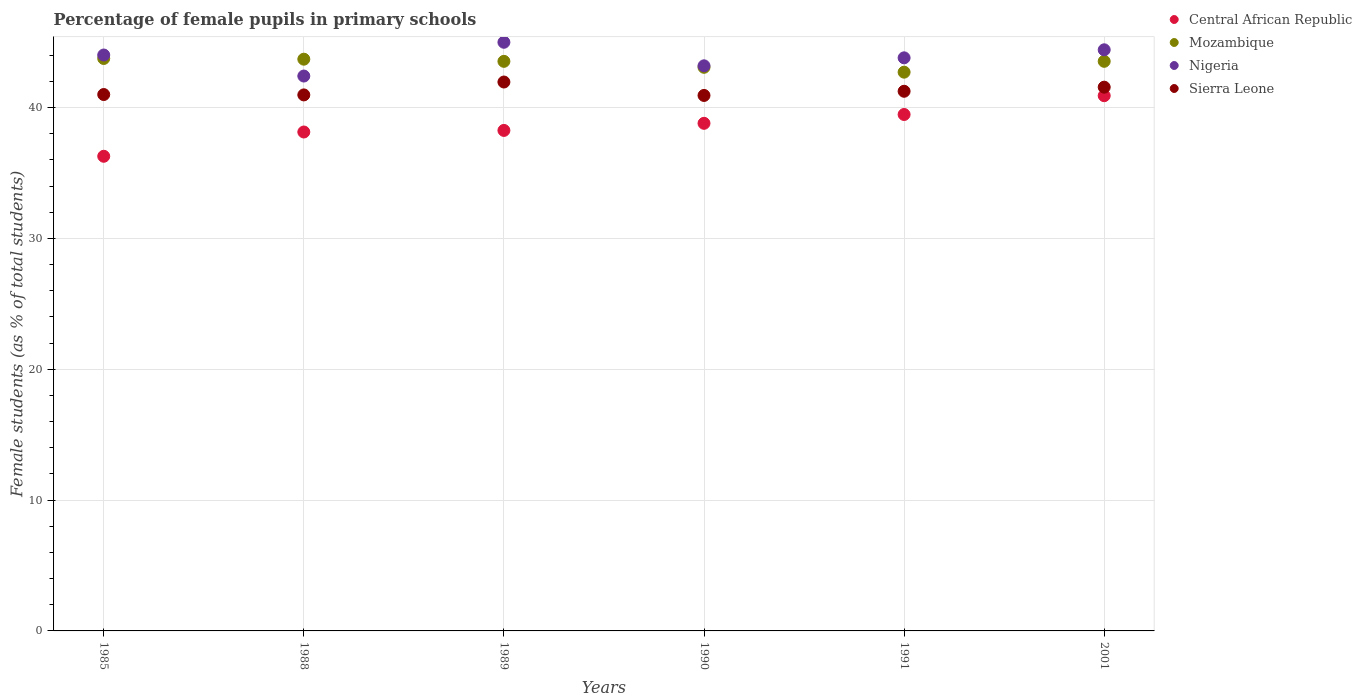What is the percentage of female pupils in primary schools in Mozambique in 1991?
Provide a succinct answer. 42.71. Across all years, what is the maximum percentage of female pupils in primary schools in Nigeria?
Offer a very short reply. 44.99. Across all years, what is the minimum percentage of female pupils in primary schools in Nigeria?
Your answer should be very brief. 42.41. What is the total percentage of female pupils in primary schools in Nigeria in the graph?
Keep it short and to the point. 262.85. What is the difference between the percentage of female pupils in primary schools in Mozambique in 1988 and that in 1991?
Keep it short and to the point. 0.99. What is the difference between the percentage of female pupils in primary schools in Central African Republic in 1985 and the percentage of female pupils in primary schools in Mozambique in 1991?
Your answer should be very brief. -6.43. What is the average percentage of female pupils in primary schools in Mozambique per year?
Offer a terse response. 43.39. In the year 1985, what is the difference between the percentage of female pupils in primary schools in Nigeria and percentage of female pupils in primary schools in Central African Republic?
Provide a short and direct response. 7.74. In how many years, is the percentage of female pupils in primary schools in Mozambique greater than 34 %?
Make the answer very short. 6. What is the ratio of the percentage of female pupils in primary schools in Sierra Leone in 1991 to that in 2001?
Provide a succinct answer. 0.99. Is the difference between the percentage of female pupils in primary schools in Nigeria in 1985 and 1989 greater than the difference between the percentage of female pupils in primary schools in Central African Republic in 1985 and 1989?
Offer a terse response. Yes. What is the difference between the highest and the second highest percentage of female pupils in primary schools in Nigeria?
Offer a very short reply. 0.58. What is the difference between the highest and the lowest percentage of female pupils in primary schools in Nigeria?
Keep it short and to the point. 2.58. In how many years, is the percentage of female pupils in primary schools in Sierra Leone greater than the average percentage of female pupils in primary schools in Sierra Leone taken over all years?
Your answer should be compact. 2. Is it the case that in every year, the sum of the percentage of female pupils in primary schools in Sierra Leone and percentage of female pupils in primary schools in Nigeria  is greater than the percentage of female pupils in primary schools in Mozambique?
Ensure brevity in your answer.  Yes. Does the percentage of female pupils in primary schools in Mozambique monotonically increase over the years?
Ensure brevity in your answer.  No. Is the percentage of female pupils in primary schools in Mozambique strictly greater than the percentage of female pupils in primary schools in Nigeria over the years?
Ensure brevity in your answer.  No. How many dotlines are there?
Offer a very short reply. 4. How many years are there in the graph?
Keep it short and to the point. 6. Are the values on the major ticks of Y-axis written in scientific E-notation?
Your answer should be compact. No. Where does the legend appear in the graph?
Your answer should be very brief. Top right. What is the title of the graph?
Offer a very short reply. Percentage of female pupils in primary schools. What is the label or title of the Y-axis?
Give a very brief answer. Female students (as % of total students). What is the Female students (as % of total students) in Central African Republic in 1985?
Provide a succinct answer. 36.28. What is the Female students (as % of total students) of Mozambique in 1985?
Offer a very short reply. 43.76. What is the Female students (as % of total students) of Nigeria in 1985?
Offer a very short reply. 44.02. What is the Female students (as % of total students) of Sierra Leone in 1985?
Your answer should be compact. 41. What is the Female students (as % of total students) in Central African Republic in 1988?
Give a very brief answer. 38.14. What is the Female students (as % of total students) in Mozambique in 1988?
Your answer should be compact. 43.7. What is the Female students (as % of total students) of Nigeria in 1988?
Offer a very short reply. 42.41. What is the Female students (as % of total students) of Sierra Leone in 1988?
Keep it short and to the point. 40.97. What is the Female students (as % of total students) of Central African Republic in 1989?
Offer a terse response. 38.26. What is the Female students (as % of total students) of Mozambique in 1989?
Provide a short and direct response. 43.54. What is the Female students (as % of total students) of Nigeria in 1989?
Give a very brief answer. 44.99. What is the Female students (as % of total students) in Sierra Leone in 1989?
Your answer should be compact. 41.96. What is the Female students (as % of total students) of Central African Republic in 1990?
Provide a short and direct response. 38.8. What is the Female students (as % of total students) in Mozambique in 1990?
Ensure brevity in your answer.  43.08. What is the Female students (as % of total students) in Nigeria in 1990?
Make the answer very short. 43.19. What is the Female students (as % of total students) in Sierra Leone in 1990?
Make the answer very short. 40.93. What is the Female students (as % of total students) of Central African Republic in 1991?
Your answer should be compact. 39.47. What is the Female students (as % of total students) in Mozambique in 1991?
Make the answer very short. 42.71. What is the Female students (as % of total students) of Nigeria in 1991?
Offer a terse response. 43.81. What is the Female students (as % of total students) of Sierra Leone in 1991?
Your answer should be compact. 41.25. What is the Female students (as % of total students) in Central African Republic in 2001?
Your answer should be compact. 40.91. What is the Female students (as % of total students) of Mozambique in 2001?
Your answer should be compact. 43.54. What is the Female students (as % of total students) of Nigeria in 2001?
Provide a succinct answer. 44.42. What is the Female students (as % of total students) in Sierra Leone in 2001?
Your answer should be very brief. 41.56. Across all years, what is the maximum Female students (as % of total students) of Central African Republic?
Make the answer very short. 40.91. Across all years, what is the maximum Female students (as % of total students) of Mozambique?
Make the answer very short. 43.76. Across all years, what is the maximum Female students (as % of total students) of Nigeria?
Offer a terse response. 44.99. Across all years, what is the maximum Female students (as % of total students) of Sierra Leone?
Offer a terse response. 41.96. Across all years, what is the minimum Female students (as % of total students) in Central African Republic?
Make the answer very short. 36.28. Across all years, what is the minimum Female students (as % of total students) of Mozambique?
Provide a short and direct response. 42.71. Across all years, what is the minimum Female students (as % of total students) in Nigeria?
Your answer should be compact. 42.41. Across all years, what is the minimum Female students (as % of total students) of Sierra Leone?
Provide a short and direct response. 40.93. What is the total Female students (as % of total students) of Central African Republic in the graph?
Keep it short and to the point. 231.86. What is the total Female students (as % of total students) of Mozambique in the graph?
Your answer should be very brief. 260.32. What is the total Female students (as % of total students) of Nigeria in the graph?
Provide a short and direct response. 262.85. What is the total Female students (as % of total students) of Sierra Leone in the graph?
Offer a terse response. 247.67. What is the difference between the Female students (as % of total students) in Central African Republic in 1985 and that in 1988?
Offer a very short reply. -1.86. What is the difference between the Female students (as % of total students) in Mozambique in 1985 and that in 1988?
Make the answer very short. 0.05. What is the difference between the Female students (as % of total students) of Nigeria in 1985 and that in 1988?
Provide a succinct answer. 1.61. What is the difference between the Female students (as % of total students) in Sierra Leone in 1985 and that in 1988?
Your answer should be very brief. 0.03. What is the difference between the Female students (as % of total students) in Central African Republic in 1985 and that in 1989?
Offer a terse response. -1.98. What is the difference between the Female students (as % of total students) of Mozambique in 1985 and that in 1989?
Provide a short and direct response. 0.22. What is the difference between the Female students (as % of total students) in Nigeria in 1985 and that in 1989?
Make the answer very short. -0.97. What is the difference between the Female students (as % of total students) in Sierra Leone in 1985 and that in 1989?
Ensure brevity in your answer.  -0.96. What is the difference between the Female students (as % of total students) of Central African Republic in 1985 and that in 1990?
Offer a terse response. -2.52. What is the difference between the Female students (as % of total students) in Mozambique in 1985 and that in 1990?
Ensure brevity in your answer.  0.68. What is the difference between the Female students (as % of total students) in Nigeria in 1985 and that in 1990?
Keep it short and to the point. 0.83. What is the difference between the Female students (as % of total students) of Sierra Leone in 1985 and that in 1990?
Keep it short and to the point. 0.07. What is the difference between the Female students (as % of total students) in Central African Republic in 1985 and that in 1991?
Ensure brevity in your answer.  -3.19. What is the difference between the Female students (as % of total students) in Mozambique in 1985 and that in 1991?
Offer a very short reply. 1.05. What is the difference between the Female students (as % of total students) in Nigeria in 1985 and that in 1991?
Provide a short and direct response. 0.22. What is the difference between the Female students (as % of total students) in Sierra Leone in 1985 and that in 1991?
Give a very brief answer. -0.25. What is the difference between the Female students (as % of total students) of Central African Republic in 1985 and that in 2001?
Keep it short and to the point. -4.63. What is the difference between the Female students (as % of total students) in Mozambique in 1985 and that in 2001?
Ensure brevity in your answer.  0.22. What is the difference between the Female students (as % of total students) in Nigeria in 1985 and that in 2001?
Give a very brief answer. -0.4. What is the difference between the Female students (as % of total students) of Sierra Leone in 1985 and that in 2001?
Ensure brevity in your answer.  -0.56. What is the difference between the Female students (as % of total students) of Central African Republic in 1988 and that in 1989?
Give a very brief answer. -0.12. What is the difference between the Female students (as % of total students) of Mozambique in 1988 and that in 1989?
Keep it short and to the point. 0.17. What is the difference between the Female students (as % of total students) in Nigeria in 1988 and that in 1989?
Your answer should be very brief. -2.58. What is the difference between the Female students (as % of total students) in Sierra Leone in 1988 and that in 1989?
Offer a terse response. -0.99. What is the difference between the Female students (as % of total students) of Central African Republic in 1988 and that in 1990?
Make the answer very short. -0.66. What is the difference between the Female students (as % of total students) of Mozambique in 1988 and that in 1990?
Provide a short and direct response. 0.62. What is the difference between the Female students (as % of total students) of Nigeria in 1988 and that in 1990?
Ensure brevity in your answer.  -0.78. What is the difference between the Female students (as % of total students) in Sierra Leone in 1988 and that in 1990?
Your answer should be compact. 0.04. What is the difference between the Female students (as % of total students) of Central African Republic in 1988 and that in 1991?
Provide a succinct answer. -1.34. What is the difference between the Female students (as % of total students) in Nigeria in 1988 and that in 1991?
Your answer should be very brief. -1.39. What is the difference between the Female students (as % of total students) in Sierra Leone in 1988 and that in 1991?
Give a very brief answer. -0.28. What is the difference between the Female students (as % of total students) in Central African Republic in 1988 and that in 2001?
Offer a terse response. -2.78. What is the difference between the Female students (as % of total students) of Mozambique in 1988 and that in 2001?
Your answer should be very brief. 0.16. What is the difference between the Female students (as % of total students) in Nigeria in 1988 and that in 2001?
Your answer should be compact. -2.01. What is the difference between the Female students (as % of total students) of Sierra Leone in 1988 and that in 2001?
Your answer should be very brief. -0.59. What is the difference between the Female students (as % of total students) in Central African Republic in 1989 and that in 1990?
Make the answer very short. -0.54. What is the difference between the Female students (as % of total students) of Mozambique in 1989 and that in 1990?
Your answer should be compact. 0.46. What is the difference between the Female students (as % of total students) of Nigeria in 1989 and that in 1990?
Provide a short and direct response. 1.8. What is the difference between the Female students (as % of total students) in Sierra Leone in 1989 and that in 1990?
Provide a short and direct response. 1.03. What is the difference between the Female students (as % of total students) in Central African Republic in 1989 and that in 1991?
Make the answer very short. -1.22. What is the difference between the Female students (as % of total students) of Mozambique in 1989 and that in 1991?
Make the answer very short. 0.83. What is the difference between the Female students (as % of total students) of Nigeria in 1989 and that in 1991?
Offer a very short reply. 1.19. What is the difference between the Female students (as % of total students) in Sierra Leone in 1989 and that in 1991?
Your response must be concise. 0.71. What is the difference between the Female students (as % of total students) in Central African Republic in 1989 and that in 2001?
Ensure brevity in your answer.  -2.65. What is the difference between the Female students (as % of total students) in Mozambique in 1989 and that in 2001?
Provide a short and direct response. -0. What is the difference between the Female students (as % of total students) of Nigeria in 1989 and that in 2001?
Provide a succinct answer. 0.58. What is the difference between the Female students (as % of total students) of Sierra Leone in 1989 and that in 2001?
Your response must be concise. 0.39. What is the difference between the Female students (as % of total students) in Central African Republic in 1990 and that in 1991?
Your response must be concise. -0.68. What is the difference between the Female students (as % of total students) in Mozambique in 1990 and that in 1991?
Provide a short and direct response. 0.37. What is the difference between the Female students (as % of total students) of Nigeria in 1990 and that in 1991?
Make the answer very short. -0.61. What is the difference between the Female students (as % of total students) of Sierra Leone in 1990 and that in 1991?
Give a very brief answer. -0.32. What is the difference between the Female students (as % of total students) in Central African Republic in 1990 and that in 2001?
Your response must be concise. -2.11. What is the difference between the Female students (as % of total students) of Mozambique in 1990 and that in 2001?
Your answer should be compact. -0.46. What is the difference between the Female students (as % of total students) in Nigeria in 1990 and that in 2001?
Keep it short and to the point. -1.22. What is the difference between the Female students (as % of total students) of Sierra Leone in 1990 and that in 2001?
Your answer should be very brief. -0.63. What is the difference between the Female students (as % of total students) of Central African Republic in 1991 and that in 2001?
Provide a succinct answer. -1.44. What is the difference between the Female students (as % of total students) in Mozambique in 1991 and that in 2001?
Make the answer very short. -0.83. What is the difference between the Female students (as % of total students) of Nigeria in 1991 and that in 2001?
Provide a succinct answer. -0.61. What is the difference between the Female students (as % of total students) of Sierra Leone in 1991 and that in 2001?
Your answer should be very brief. -0.31. What is the difference between the Female students (as % of total students) in Central African Republic in 1985 and the Female students (as % of total students) in Mozambique in 1988?
Your answer should be very brief. -7.42. What is the difference between the Female students (as % of total students) in Central African Republic in 1985 and the Female students (as % of total students) in Nigeria in 1988?
Your response must be concise. -6.13. What is the difference between the Female students (as % of total students) of Central African Republic in 1985 and the Female students (as % of total students) of Sierra Leone in 1988?
Give a very brief answer. -4.69. What is the difference between the Female students (as % of total students) in Mozambique in 1985 and the Female students (as % of total students) in Nigeria in 1988?
Make the answer very short. 1.34. What is the difference between the Female students (as % of total students) of Mozambique in 1985 and the Female students (as % of total students) of Sierra Leone in 1988?
Ensure brevity in your answer.  2.78. What is the difference between the Female students (as % of total students) in Nigeria in 1985 and the Female students (as % of total students) in Sierra Leone in 1988?
Your answer should be very brief. 3.05. What is the difference between the Female students (as % of total students) of Central African Republic in 1985 and the Female students (as % of total students) of Mozambique in 1989?
Offer a terse response. -7.26. What is the difference between the Female students (as % of total students) in Central African Republic in 1985 and the Female students (as % of total students) in Nigeria in 1989?
Your answer should be compact. -8.71. What is the difference between the Female students (as % of total students) in Central African Republic in 1985 and the Female students (as % of total students) in Sierra Leone in 1989?
Make the answer very short. -5.68. What is the difference between the Female students (as % of total students) in Mozambique in 1985 and the Female students (as % of total students) in Nigeria in 1989?
Provide a succinct answer. -1.24. What is the difference between the Female students (as % of total students) in Mozambique in 1985 and the Female students (as % of total students) in Sierra Leone in 1989?
Provide a short and direct response. 1.8. What is the difference between the Female students (as % of total students) of Nigeria in 1985 and the Female students (as % of total students) of Sierra Leone in 1989?
Provide a succinct answer. 2.06. What is the difference between the Female students (as % of total students) in Central African Republic in 1985 and the Female students (as % of total students) in Mozambique in 1990?
Provide a succinct answer. -6.8. What is the difference between the Female students (as % of total students) in Central African Republic in 1985 and the Female students (as % of total students) in Nigeria in 1990?
Your response must be concise. -6.91. What is the difference between the Female students (as % of total students) in Central African Republic in 1985 and the Female students (as % of total students) in Sierra Leone in 1990?
Keep it short and to the point. -4.65. What is the difference between the Female students (as % of total students) in Mozambique in 1985 and the Female students (as % of total students) in Nigeria in 1990?
Offer a terse response. 0.56. What is the difference between the Female students (as % of total students) in Mozambique in 1985 and the Female students (as % of total students) in Sierra Leone in 1990?
Your response must be concise. 2.83. What is the difference between the Female students (as % of total students) in Nigeria in 1985 and the Female students (as % of total students) in Sierra Leone in 1990?
Make the answer very short. 3.09. What is the difference between the Female students (as % of total students) in Central African Republic in 1985 and the Female students (as % of total students) in Mozambique in 1991?
Make the answer very short. -6.43. What is the difference between the Female students (as % of total students) of Central African Republic in 1985 and the Female students (as % of total students) of Nigeria in 1991?
Give a very brief answer. -7.52. What is the difference between the Female students (as % of total students) of Central African Republic in 1985 and the Female students (as % of total students) of Sierra Leone in 1991?
Ensure brevity in your answer.  -4.97. What is the difference between the Female students (as % of total students) in Mozambique in 1985 and the Female students (as % of total students) in Nigeria in 1991?
Provide a short and direct response. -0.05. What is the difference between the Female students (as % of total students) in Mozambique in 1985 and the Female students (as % of total students) in Sierra Leone in 1991?
Provide a succinct answer. 2.51. What is the difference between the Female students (as % of total students) of Nigeria in 1985 and the Female students (as % of total students) of Sierra Leone in 1991?
Keep it short and to the point. 2.77. What is the difference between the Female students (as % of total students) in Central African Republic in 1985 and the Female students (as % of total students) in Mozambique in 2001?
Offer a terse response. -7.26. What is the difference between the Female students (as % of total students) in Central African Republic in 1985 and the Female students (as % of total students) in Nigeria in 2001?
Ensure brevity in your answer.  -8.14. What is the difference between the Female students (as % of total students) of Central African Republic in 1985 and the Female students (as % of total students) of Sierra Leone in 2001?
Your response must be concise. -5.28. What is the difference between the Female students (as % of total students) in Mozambique in 1985 and the Female students (as % of total students) in Nigeria in 2001?
Ensure brevity in your answer.  -0.66. What is the difference between the Female students (as % of total students) in Mozambique in 1985 and the Female students (as % of total students) in Sierra Leone in 2001?
Provide a short and direct response. 2.19. What is the difference between the Female students (as % of total students) in Nigeria in 1985 and the Female students (as % of total students) in Sierra Leone in 2001?
Keep it short and to the point. 2.46. What is the difference between the Female students (as % of total students) of Central African Republic in 1988 and the Female students (as % of total students) of Mozambique in 1989?
Make the answer very short. -5.4. What is the difference between the Female students (as % of total students) of Central African Republic in 1988 and the Female students (as % of total students) of Nigeria in 1989?
Offer a very short reply. -6.86. What is the difference between the Female students (as % of total students) in Central African Republic in 1988 and the Female students (as % of total students) in Sierra Leone in 1989?
Offer a very short reply. -3.82. What is the difference between the Female students (as % of total students) of Mozambique in 1988 and the Female students (as % of total students) of Nigeria in 1989?
Ensure brevity in your answer.  -1.29. What is the difference between the Female students (as % of total students) in Mozambique in 1988 and the Female students (as % of total students) in Sierra Leone in 1989?
Your response must be concise. 1.75. What is the difference between the Female students (as % of total students) of Nigeria in 1988 and the Female students (as % of total students) of Sierra Leone in 1989?
Ensure brevity in your answer.  0.46. What is the difference between the Female students (as % of total students) of Central African Republic in 1988 and the Female students (as % of total students) of Mozambique in 1990?
Keep it short and to the point. -4.95. What is the difference between the Female students (as % of total students) in Central African Republic in 1988 and the Female students (as % of total students) in Nigeria in 1990?
Your answer should be very brief. -5.06. What is the difference between the Female students (as % of total students) in Central African Republic in 1988 and the Female students (as % of total students) in Sierra Leone in 1990?
Offer a very short reply. -2.79. What is the difference between the Female students (as % of total students) in Mozambique in 1988 and the Female students (as % of total students) in Nigeria in 1990?
Your response must be concise. 0.51. What is the difference between the Female students (as % of total students) in Mozambique in 1988 and the Female students (as % of total students) in Sierra Leone in 1990?
Offer a terse response. 2.77. What is the difference between the Female students (as % of total students) of Nigeria in 1988 and the Female students (as % of total students) of Sierra Leone in 1990?
Give a very brief answer. 1.48. What is the difference between the Female students (as % of total students) in Central African Republic in 1988 and the Female students (as % of total students) in Mozambique in 1991?
Provide a succinct answer. -4.57. What is the difference between the Female students (as % of total students) of Central African Republic in 1988 and the Female students (as % of total students) of Nigeria in 1991?
Keep it short and to the point. -5.67. What is the difference between the Female students (as % of total students) of Central African Republic in 1988 and the Female students (as % of total students) of Sierra Leone in 1991?
Offer a terse response. -3.11. What is the difference between the Female students (as % of total students) of Mozambique in 1988 and the Female students (as % of total students) of Nigeria in 1991?
Keep it short and to the point. -0.1. What is the difference between the Female students (as % of total students) in Mozambique in 1988 and the Female students (as % of total students) in Sierra Leone in 1991?
Provide a succinct answer. 2.45. What is the difference between the Female students (as % of total students) of Nigeria in 1988 and the Female students (as % of total students) of Sierra Leone in 1991?
Ensure brevity in your answer.  1.16. What is the difference between the Female students (as % of total students) of Central African Republic in 1988 and the Female students (as % of total students) of Mozambique in 2001?
Offer a terse response. -5.4. What is the difference between the Female students (as % of total students) in Central African Republic in 1988 and the Female students (as % of total students) in Nigeria in 2001?
Your answer should be compact. -6.28. What is the difference between the Female students (as % of total students) in Central African Republic in 1988 and the Female students (as % of total students) in Sierra Leone in 2001?
Offer a terse response. -3.43. What is the difference between the Female students (as % of total students) of Mozambique in 1988 and the Female students (as % of total students) of Nigeria in 2001?
Make the answer very short. -0.72. What is the difference between the Female students (as % of total students) in Mozambique in 1988 and the Female students (as % of total students) in Sierra Leone in 2001?
Keep it short and to the point. 2.14. What is the difference between the Female students (as % of total students) of Nigeria in 1988 and the Female students (as % of total students) of Sierra Leone in 2001?
Keep it short and to the point. 0.85. What is the difference between the Female students (as % of total students) of Central African Republic in 1989 and the Female students (as % of total students) of Mozambique in 1990?
Keep it short and to the point. -4.82. What is the difference between the Female students (as % of total students) in Central African Republic in 1989 and the Female students (as % of total students) in Nigeria in 1990?
Your answer should be very brief. -4.94. What is the difference between the Female students (as % of total students) in Central African Republic in 1989 and the Female students (as % of total students) in Sierra Leone in 1990?
Your answer should be compact. -2.67. What is the difference between the Female students (as % of total students) of Mozambique in 1989 and the Female students (as % of total students) of Nigeria in 1990?
Your answer should be compact. 0.34. What is the difference between the Female students (as % of total students) in Mozambique in 1989 and the Female students (as % of total students) in Sierra Leone in 1990?
Keep it short and to the point. 2.61. What is the difference between the Female students (as % of total students) in Nigeria in 1989 and the Female students (as % of total students) in Sierra Leone in 1990?
Make the answer very short. 4.06. What is the difference between the Female students (as % of total students) in Central African Republic in 1989 and the Female students (as % of total students) in Mozambique in 1991?
Ensure brevity in your answer.  -4.45. What is the difference between the Female students (as % of total students) in Central African Republic in 1989 and the Female students (as % of total students) in Nigeria in 1991?
Your answer should be very brief. -5.55. What is the difference between the Female students (as % of total students) of Central African Republic in 1989 and the Female students (as % of total students) of Sierra Leone in 1991?
Offer a terse response. -2.99. What is the difference between the Female students (as % of total students) in Mozambique in 1989 and the Female students (as % of total students) in Nigeria in 1991?
Provide a short and direct response. -0.27. What is the difference between the Female students (as % of total students) in Mozambique in 1989 and the Female students (as % of total students) in Sierra Leone in 1991?
Offer a terse response. 2.29. What is the difference between the Female students (as % of total students) of Nigeria in 1989 and the Female students (as % of total students) of Sierra Leone in 1991?
Your answer should be compact. 3.74. What is the difference between the Female students (as % of total students) of Central African Republic in 1989 and the Female students (as % of total students) of Mozambique in 2001?
Keep it short and to the point. -5.28. What is the difference between the Female students (as % of total students) in Central African Republic in 1989 and the Female students (as % of total students) in Nigeria in 2001?
Your answer should be very brief. -6.16. What is the difference between the Female students (as % of total students) in Central African Republic in 1989 and the Female students (as % of total students) in Sierra Leone in 2001?
Offer a very short reply. -3.31. What is the difference between the Female students (as % of total students) in Mozambique in 1989 and the Female students (as % of total students) in Nigeria in 2001?
Make the answer very short. -0.88. What is the difference between the Female students (as % of total students) in Mozambique in 1989 and the Female students (as % of total students) in Sierra Leone in 2001?
Your answer should be compact. 1.97. What is the difference between the Female students (as % of total students) of Nigeria in 1989 and the Female students (as % of total students) of Sierra Leone in 2001?
Ensure brevity in your answer.  3.43. What is the difference between the Female students (as % of total students) of Central African Republic in 1990 and the Female students (as % of total students) of Mozambique in 1991?
Your answer should be very brief. -3.91. What is the difference between the Female students (as % of total students) in Central African Republic in 1990 and the Female students (as % of total students) in Nigeria in 1991?
Ensure brevity in your answer.  -5.01. What is the difference between the Female students (as % of total students) in Central African Republic in 1990 and the Female students (as % of total students) in Sierra Leone in 1991?
Your answer should be compact. -2.45. What is the difference between the Female students (as % of total students) in Mozambique in 1990 and the Female students (as % of total students) in Nigeria in 1991?
Keep it short and to the point. -0.72. What is the difference between the Female students (as % of total students) in Mozambique in 1990 and the Female students (as % of total students) in Sierra Leone in 1991?
Keep it short and to the point. 1.83. What is the difference between the Female students (as % of total students) of Nigeria in 1990 and the Female students (as % of total students) of Sierra Leone in 1991?
Ensure brevity in your answer.  1.95. What is the difference between the Female students (as % of total students) of Central African Republic in 1990 and the Female students (as % of total students) of Mozambique in 2001?
Make the answer very short. -4.74. What is the difference between the Female students (as % of total students) in Central African Republic in 1990 and the Female students (as % of total students) in Nigeria in 2001?
Offer a very short reply. -5.62. What is the difference between the Female students (as % of total students) of Central African Republic in 1990 and the Female students (as % of total students) of Sierra Leone in 2001?
Provide a short and direct response. -2.76. What is the difference between the Female students (as % of total students) in Mozambique in 1990 and the Female students (as % of total students) in Nigeria in 2001?
Keep it short and to the point. -1.34. What is the difference between the Female students (as % of total students) of Mozambique in 1990 and the Female students (as % of total students) of Sierra Leone in 2001?
Provide a succinct answer. 1.52. What is the difference between the Female students (as % of total students) of Nigeria in 1990 and the Female students (as % of total students) of Sierra Leone in 2001?
Your response must be concise. 1.63. What is the difference between the Female students (as % of total students) of Central African Republic in 1991 and the Female students (as % of total students) of Mozambique in 2001?
Provide a succinct answer. -4.06. What is the difference between the Female students (as % of total students) of Central African Republic in 1991 and the Female students (as % of total students) of Nigeria in 2001?
Keep it short and to the point. -4.94. What is the difference between the Female students (as % of total students) of Central African Republic in 1991 and the Female students (as % of total students) of Sierra Leone in 2001?
Your answer should be compact. -2.09. What is the difference between the Female students (as % of total students) of Mozambique in 1991 and the Female students (as % of total students) of Nigeria in 2001?
Provide a succinct answer. -1.71. What is the difference between the Female students (as % of total students) in Mozambique in 1991 and the Female students (as % of total students) in Sierra Leone in 2001?
Your answer should be compact. 1.15. What is the difference between the Female students (as % of total students) of Nigeria in 1991 and the Female students (as % of total students) of Sierra Leone in 2001?
Your answer should be very brief. 2.24. What is the average Female students (as % of total students) in Central African Republic per year?
Your answer should be very brief. 38.64. What is the average Female students (as % of total students) in Mozambique per year?
Offer a terse response. 43.39. What is the average Female students (as % of total students) in Nigeria per year?
Give a very brief answer. 43.81. What is the average Female students (as % of total students) of Sierra Leone per year?
Your answer should be compact. 41.28. In the year 1985, what is the difference between the Female students (as % of total students) of Central African Republic and Female students (as % of total students) of Mozambique?
Keep it short and to the point. -7.48. In the year 1985, what is the difference between the Female students (as % of total students) in Central African Republic and Female students (as % of total students) in Nigeria?
Your response must be concise. -7.74. In the year 1985, what is the difference between the Female students (as % of total students) in Central African Republic and Female students (as % of total students) in Sierra Leone?
Your response must be concise. -4.72. In the year 1985, what is the difference between the Female students (as % of total students) of Mozambique and Female students (as % of total students) of Nigeria?
Provide a short and direct response. -0.26. In the year 1985, what is the difference between the Female students (as % of total students) of Mozambique and Female students (as % of total students) of Sierra Leone?
Make the answer very short. 2.76. In the year 1985, what is the difference between the Female students (as % of total students) in Nigeria and Female students (as % of total students) in Sierra Leone?
Offer a terse response. 3.02. In the year 1988, what is the difference between the Female students (as % of total students) in Central African Republic and Female students (as % of total students) in Mozambique?
Give a very brief answer. -5.57. In the year 1988, what is the difference between the Female students (as % of total students) of Central African Republic and Female students (as % of total students) of Nigeria?
Your answer should be compact. -4.28. In the year 1988, what is the difference between the Female students (as % of total students) of Central African Republic and Female students (as % of total students) of Sierra Leone?
Give a very brief answer. -2.84. In the year 1988, what is the difference between the Female students (as % of total students) of Mozambique and Female students (as % of total students) of Nigeria?
Your response must be concise. 1.29. In the year 1988, what is the difference between the Female students (as % of total students) of Mozambique and Female students (as % of total students) of Sierra Leone?
Provide a short and direct response. 2.73. In the year 1988, what is the difference between the Female students (as % of total students) of Nigeria and Female students (as % of total students) of Sierra Leone?
Your response must be concise. 1.44. In the year 1989, what is the difference between the Female students (as % of total students) of Central African Republic and Female students (as % of total students) of Mozambique?
Ensure brevity in your answer.  -5.28. In the year 1989, what is the difference between the Female students (as % of total students) in Central African Republic and Female students (as % of total students) in Nigeria?
Give a very brief answer. -6.74. In the year 1989, what is the difference between the Female students (as % of total students) of Central African Republic and Female students (as % of total students) of Sierra Leone?
Keep it short and to the point. -3.7. In the year 1989, what is the difference between the Female students (as % of total students) of Mozambique and Female students (as % of total students) of Nigeria?
Ensure brevity in your answer.  -1.46. In the year 1989, what is the difference between the Female students (as % of total students) of Mozambique and Female students (as % of total students) of Sierra Leone?
Ensure brevity in your answer.  1.58. In the year 1989, what is the difference between the Female students (as % of total students) of Nigeria and Female students (as % of total students) of Sierra Leone?
Make the answer very short. 3.04. In the year 1990, what is the difference between the Female students (as % of total students) in Central African Republic and Female students (as % of total students) in Mozambique?
Your answer should be very brief. -4.28. In the year 1990, what is the difference between the Female students (as % of total students) in Central African Republic and Female students (as % of total students) in Nigeria?
Ensure brevity in your answer.  -4.4. In the year 1990, what is the difference between the Female students (as % of total students) of Central African Republic and Female students (as % of total students) of Sierra Leone?
Your response must be concise. -2.13. In the year 1990, what is the difference between the Female students (as % of total students) of Mozambique and Female students (as % of total students) of Nigeria?
Your answer should be very brief. -0.11. In the year 1990, what is the difference between the Female students (as % of total students) in Mozambique and Female students (as % of total students) in Sierra Leone?
Offer a terse response. 2.15. In the year 1990, what is the difference between the Female students (as % of total students) in Nigeria and Female students (as % of total students) in Sierra Leone?
Provide a succinct answer. 2.26. In the year 1991, what is the difference between the Female students (as % of total students) in Central African Republic and Female students (as % of total students) in Mozambique?
Your response must be concise. -3.23. In the year 1991, what is the difference between the Female students (as % of total students) of Central African Republic and Female students (as % of total students) of Nigeria?
Your response must be concise. -4.33. In the year 1991, what is the difference between the Female students (as % of total students) of Central African Republic and Female students (as % of total students) of Sierra Leone?
Keep it short and to the point. -1.77. In the year 1991, what is the difference between the Female students (as % of total students) in Mozambique and Female students (as % of total students) in Nigeria?
Offer a very short reply. -1.1. In the year 1991, what is the difference between the Female students (as % of total students) in Mozambique and Female students (as % of total students) in Sierra Leone?
Offer a terse response. 1.46. In the year 1991, what is the difference between the Female students (as % of total students) of Nigeria and Female students (as % of total students) of Sierra Leone?
Provide a succinct answer. 2.56. In the year 2001, what is the difference between the Female students (as % of total students) in Central African Republic and Female students (as % of total students) in Mozambique?
Make the answer very short. -2.63. In the year 2001, what is the difference between the Female students (as % of total students) of Central African Republic and Female students (as % of total students) of Nigeria?
Provide a short and direct response. -3.51. In the year 2001, what is the difference between the Female students (as % of total students) in Central African Republic and Female students (as % of total students) in Sierra Leone?
Your answer should be compact. -0.65. In the year 2001, what is the difference between the Female students (as % of total students) in Mozambique and Female students (as % of total students) in Nigeria?
Your answer should be compact. -0.88. In the year 2001, what is the difference between the Female students (as % of total students) in Mozambique and Female students (as % of total students) in Sierra Leone?
Keep it short and to the point. 1.98. In the year 2001, what is the difference between the Female students (as % of total students) in Nigeria and Female students (as % of total students) in Sierra Leone?
Offer a terse response. 2.86. What is the ratio of the Female students (as % of total students) of Central African Republic in 1985 to that in 1988?
Provide a succinct answer. 0.95. What is the ratio of the Female students (as % of total students) in Nigeria in 1985 to that in 1988?
Your answer should be very brief. 1.04. What is the ratio of the Female students (as % of total students) in Sierra Leone in 1985 to that in 1988?
Give a very brief answer. 1. What is the ratio of the Female students (as % of total students) of Central African Republic in 1985 to that in 1989?
Offer a very short reply. 0.95. What is the ratio of the Female students (as % of total students) in Mozambique in 1985 to that in 1989?
Your response must be concise. 1. What is the ratio of the Female students (as % of total students) in Nigeria in 1985 to that in 1989?
Offer a very short reply. 0.98. What is the ratio of the Female students (as % of total students) of Sierra Leone in 1985 to that in 1989?
Offer a very short reply. 0.98. What is the ratio of the Female students (as % of total students) of Central African Republic in 1985 to that in 1990?
Ensure brevity in your answer.  0.94. What is the ratio of the Female students (as % of total students) in Mozambique in 1985 to that in 1990?
Your answer should be very brief. 1.02. What is the ratio of the Female students (as % of total students) in Nigeria in 1985 to that in 1990?
Offer a very short reply. 1.02. What is the ratio of the Female students (as % of total students) in Central African Republic in 1985 to that in 1991?
Provide a short and direct response. 0.92. What is the ratio of the Female students (as % of total students) in Mozambique in 1985 to that in 1991?
Your response must be concise. 1.02. What is the ratio of the Female students (as % of total students) in Nigeria in 1985 to that in 1991?
Your answer should be very brief. 1. What is the ratio of the Female students (as % of total students) in Central African Republic in 1985 to that in 2001?
Ensure brevity in your answer.  0.89. What is the ratio of the Female students (as % of total students) in Mozambique in 1985 to that in 2001?
Ensure brevity in your answer.  1. What is the ratio of the Female students (as % of total students) of Sierra Leone in 1985 to that in 2001?
Your answer should be compact. 0.99. What is the ratio of the Female students (as % of total students) in Central African Republic in 1988 to that in 1989?
Ensure brevity in your answer.  1. What is the ratio of the Female students (as % of total students) in Mozambique in 1988 to that in 1989?
Keep it short and to the point. 1. What is the ratio of the Female students (as % of total students) of Nigeria in 1988 to that in 1989?
Give a very brief answer. 0.94. What is the ratio of the Female students (as % of total students) of Sierra Leone in 1988 to that in 1989?
Give a very brief answer. 0.98. What is the ratio of the Female students (as % of total students) of Central African Republic in 1988 to that in 1990?
Make the answer very short. 0.98. What is the ratio of the Female students (as % of total students) in Mozambique in 1988 to that in 1990?
Ensure brevity in your answer.  1.01. What is the ratio of the Female students (as % of total students) of Nigeria in 1988 to that in 1990?
Provide a succinct answer. 0.98. What is the ratio of the Female students (as % of total students) in Central African Republic in 1988 to that in 1991?
Provide a succinct answer. 0.97. What is the ratio of the Female students (as % of total students) of Mozambique in 1988 to that in 1991?
Provide a short and direct response. 1.02. What is the ratio of the Female students (as % of total students) in Nigeria in 1988 to that in 1991?
Provide a succinct answer. 0.97. What is the ratio of the Female students (as % of total students) of Sierra Leone in 1988 to that in 1991?
Ensure brevity in your answer.  0.99. What is the ratio of the Female students (as % of total students) of Central African Republic in 1988 to that in 2001?
Your response must be concise. 0.93. What is the ratio of the Female students (as % of total students) in Nigeria in 1988 to that in 2001?
Offer a terse response. 0.95. What is the ratio of the Female students (as % of total students) of Sierra Leone in 1988 to that in 2001?
Your response must be concise. 0.99. What is the ratio of the Female students (as % of total students) in Central African Republic in 1989 to that in 1990?
Ensure brevity in your answer.  0.99. What is the ratio of the Female students (as % of total students) of Mozambique in 1989 to that in 1990?
Give a very brief answer. 1.01. What is the ratio of the Female students (as % of total students) of Nigeria in 1989 to that in 1990?
Your answer should be compact. 1.04. What is the ratio of the Female students (as % of total students) of Sierra Leone in 1989 to that in 1990?
Offer a terse response. 1.03. What is the ratio of the Female students (as % of total students) of Central African Republic in 1989 to that in 1991?
Provide a succinct answer. 0.97. What is the ratio of the Female students (as % of total students) in Mozambique in 1989 to that in 1991?
Give a very brief answer. 1.02. What is the ratio of the Female students (as % of total students) in Nigeria in 1989 to that in 1991?
Offer a terse response. 1.03. What is the ratio of the Female students (as % of total students) of Sierra Leone in 1989 to that in 1991?
Your answer should be very brief. 1.02. What is the ratio of the Female students (as % of total students) in Central African Republic in 1989 to that in 2001?
Give a very brief answer. 0.94. What is the ratio of the Female students (as % of total students) of Mozambique in 1989 to that in 2001?
Offer a very short reply. 1. What is the ratio of the Female students (as % of total students) of Sierra Leone in 1989 to that in 2001?
Provide a short and direct response. 1.01. What is the ratio of the Female students (as % of total students) of Central African Republic in 1990 to that in 1991?
Offer a very short reply. 0.98. What is the ratio of the Female students (as % of total students) of Mozambique in 1990 to that in 1991?
Give a very brief answer. 1.01. What is the ratio of the Female students (as % of total students) of Nigeria in 1990 to that in 1991?
Your answer should be compact. 0.99. What is the ratio of the Female students (as % of total students) of Sierra Leone in 1990 to that in 1991?
Provide a short and direct response. 0.99. What is the ratio of the Female students (as % of total students) of Central African Republic in 1990 to that in 2001?
Keep it short and to the point. 0.95. What is the ratio of the Female students (as % of total students) in Mozambique in 1990 to that in 2001?
Offer a terse response. 0.99. What is the ratio of the Female students (as % of total students) of Nigeria in 1990 to that in 2001?
Your answer should be very brief. 0.97. What is the ratio of the Female students (as % of total students) of Sierra Leone in 1990 to that in 2001?
Provide a short and direct response. 0.98. What is the ratio of the Female students (as % of total students) in Central African Republic in 1991 to that in 2001?
Keep it short and to the point. 0.96. What is the ratio of the Female students (as % of total students) in Nigeria in 1991 to that in 2001?
Provide a short and direct response. 0.99. What is the difference between the highest and the second highest Female students (as % of total students) of Central African Republic?
Provide a succinct answer. 1.44. What is the difference between the highest and the second highest Female students (as % of total students) in Mozambique?
Your answer should be very brief. 0.05. What is the difference between the highest and the second highest Female students (as % of total students) in Nigeria?
Ensure brevity in your answer.  0.58. What is the difference between the highest and the second highest Female students (as % of total students) in Sierra Leone?
Your answer should be compact. 0.39. What is the difference between the highest and the lowest Female students (as % of total students) in Central African Republic?
Your answer should be compact. 4.63. What is the difference between the highest and the lowest Female students (as % of total students) in Mozambique?
Provide a succinct answer. 1.05. What is the difference between the highest and the lowest Female students (as % of total students) of Nigeria?
Give a very brief answer. 2.58. What is the difference between the highest and the lowest Female students (as % of total students) in Sierra Leone?
Provide a succinct answer. 1.03. 